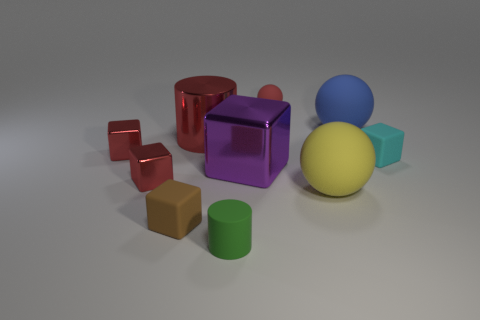Subtract all blue cubes. Subtract all cyan cylinders. How many cubes are left? 5 Subtract all spheres. How many objects are left? 7 Subtract 0 blue cylinders. How many objects are left? 10 Subtract all tiny gray rubber cylinders. Subtract all tiny green cylinders. How many objects are left? 9 Add 2 big matte balls. How many big matte balls are left? 4 Add 8 metallic balls. How many metallic balls exist? 8 